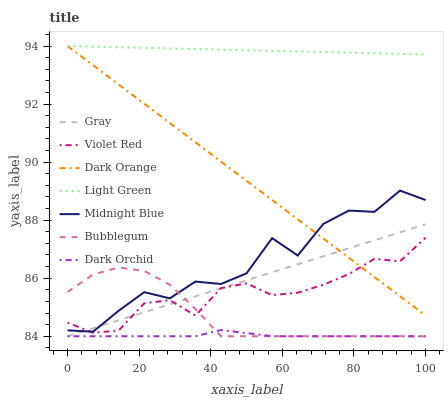Does Dark Orchid have the minimum area under the curve?
Answer yes or no. Yes. Does Light Green have the maximum area under the curve?
Answer yes or no. Yes. Does Violet Red have the minimum area under the curve?
Answer yes or no. No. Does Violet Red have the maximum area under the curve?
Answer yes or no. No. Is Gray the smoothest?
Answer yes or no. Yes. Is Midnight Blue the roughest?
Answer yes or no. Yes. Is Violet Red the smoothest?
Answer yes or no. No. Is Violet Red the roughest?
Answer yes or no. No. Does Violet Red have the lowest value?
Answer yes or no. No. Does Light Green have the highest value?
Answer yes or no. Yes. Does Violet Red have the highest value?
Answer yes or no. No. Is Dark Orchid less than Violet Red?
Answer yes or no. Yes. Is Light Green greater than Violet Red?
Answer yes or no. Yes. Does Bubblegum intersect Violet Red?
Answer yes or no. Yes. Is Bubblegum less than Violet Red?
Answer yes or no. No. Is Bubblegum greater than Violet Red?
Answer yes or no. No. Does Dark Orchid intersect Violet Red?
Answer yes or no. No. 